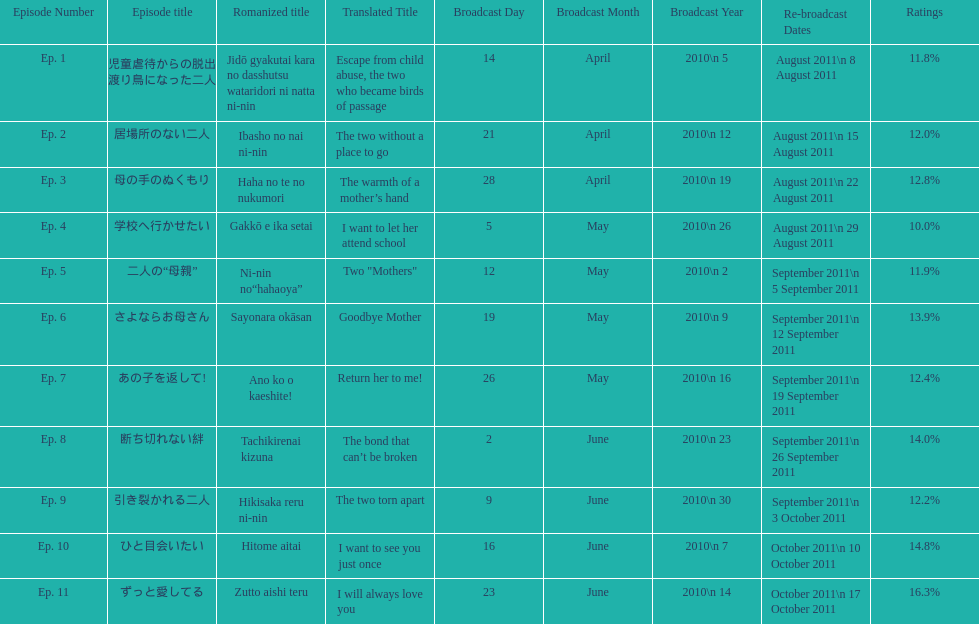Could you parse the entire table? {'header': ['Episode Number', 'Episode title', 'Romanized title', 'Translated Title', 'Broadcast Day', 'Broadcast Month', 'Broadcast Year', 'Re-broadcast Dates', 'Ratings'], 'rows': [['Ep. 1', '児童虐待からの脱出 渡り鳥になった二人', 'Jidō gyakutai kara no dasshutsu wataridori ni natta ni-nin', 'Escape from child abuse, the two who became birds of passage', '14', 'April', '2010\\n 5', 'August 2011\\n 8 August 2011', '11.8%'], ['Ep. 2', '居場所のない二人', 'Ibasho no nai ni-nin', 'The two without a place to go', '21', 'April', '2010\\n 12', 'August 2011\\n 15 August 2011', '12.0%'], ['Ep. 3', '母の手のぬくもり', 'Haha no te no nukumori', 'The warmth of a mother’s hand', '28', 'April', '2010\\n 19', 'August 2011\\n 22 August 2011', '12.8%'], ['Ep. 4', '学校へ行かせたい', 'Gakkō e ika setai', 'I want to let her attend school', '5', 'May', '2010\\n 26', 'August 2011\\n 29 August 2011', '10.0%'], ['Ep. 5', '二人の“母親”', 'Ni-nin no“hahaoya”', 'Two "Mothers"', '12', 'May', '2010\\n 2', 'September 2011\\n 5 September 2011', '11.9%'], ['Ep. 6', 'さよならお母さん', 'Sayonara okāsan', 'Goodbye Mother', '19', 'May', '2010\\n 9', 'September 2011\\n 12 September 2011', '13.9%'], ['Ep. 7', 'あの子を返して!', 'Ano ko o kaeshite!', 'Return her to me!', '26', 'May', '2010\\n 16', 'September 2011\\n 19 September 2011', '12.4%'], ['Ep. 8', '断ち切れない絆', 'Tachikirenai kizuna', 'The bond that can’t be broken', '2', 'June', '2010\\n 23', 'September 2011\\n 26 September 2011', '14.0%'], ['Ep. 9', '引き裂かれる二人', 'Hikisaka reru ni-nin', 'The two torn apart', '9', 'June', '2010\\n 30', 'September 2011\\n 3 October 2011', '12.2%'], ['Ep. 10', 'ひと目会いたい', 'Hitome aitai', 'I want to see you just once', '16', 'June', '2010\\n 7', 'October 2011\\n 10 October 2011', '14.8%'], ['Ep. 11', 'ずっと愛してる', 'Zutto aishi teru', 'I will always love you', '23', 'June', '2010\\n 14', 'October 2011\\n 17 October 2011', '16.3%']]} How many episode total are there? 11. 